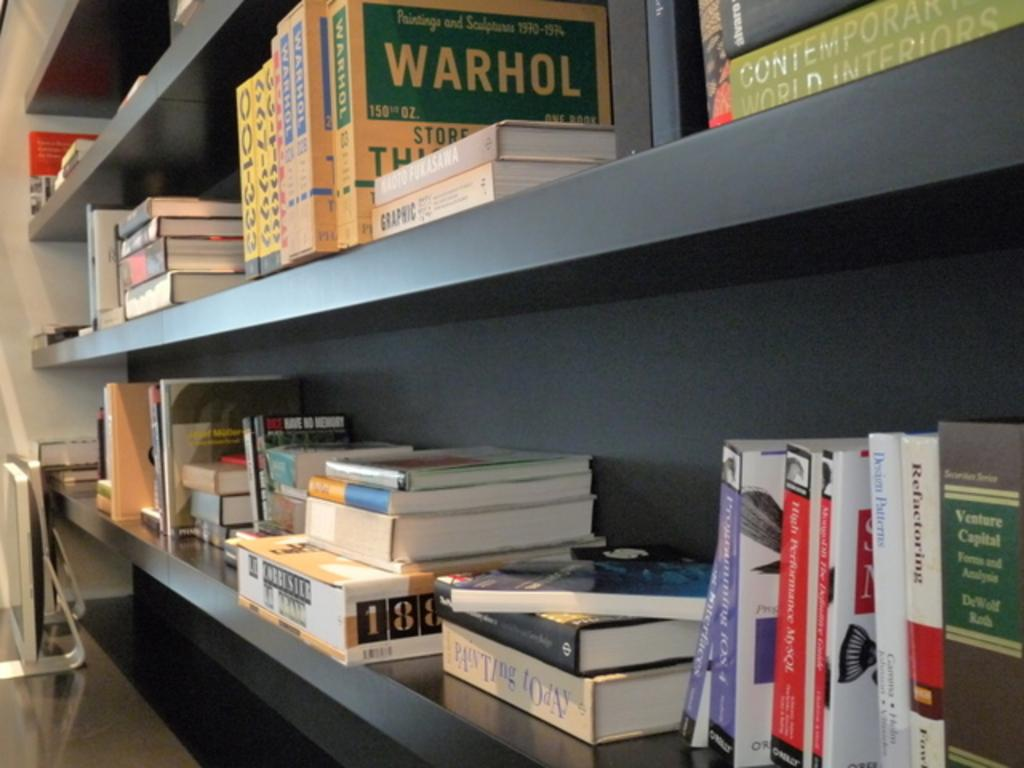<image>
Present a compact description of the photo's key features. Books and materials on a classroom shelf include information about Warhol and titles such as Contemporary World Interiors and Painting Today. 